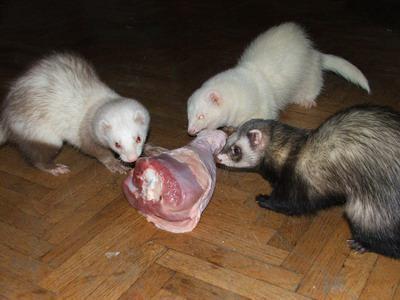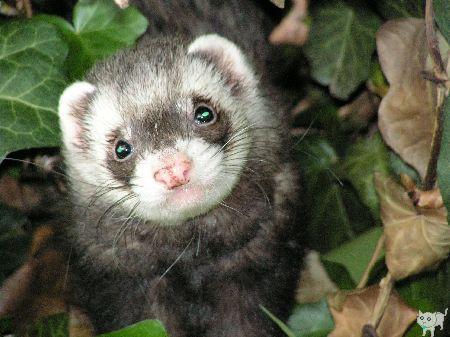The first image is the image on the left, the second image is the image on the right. Evaluate the accuracy of this statement regarding the images: "An image shows exactly one ferret standing on a dirt ground.". Is it true? Answer yes or no. No. The first image is the image on the left, the second image is the image on the right. Evaluate the accuracy of this statement regarding the images: "There is a ferret in the outdoors looking directly at the camera in the right image.". Is it true? Answer yes or no. Yes. 